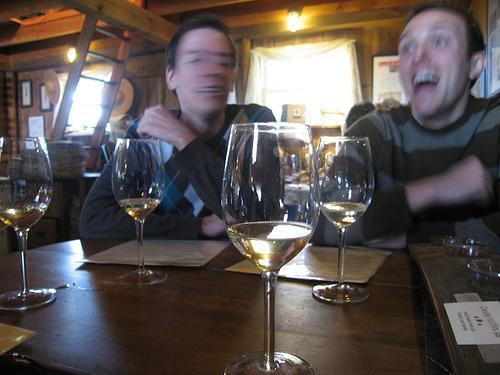How many people are in the picture?
Give a very brief answer. 2. How many wine glasses are there?
Give a very brief answer. 2. How many of the umbrellas are folded?
Give a very brief answer. 0. 